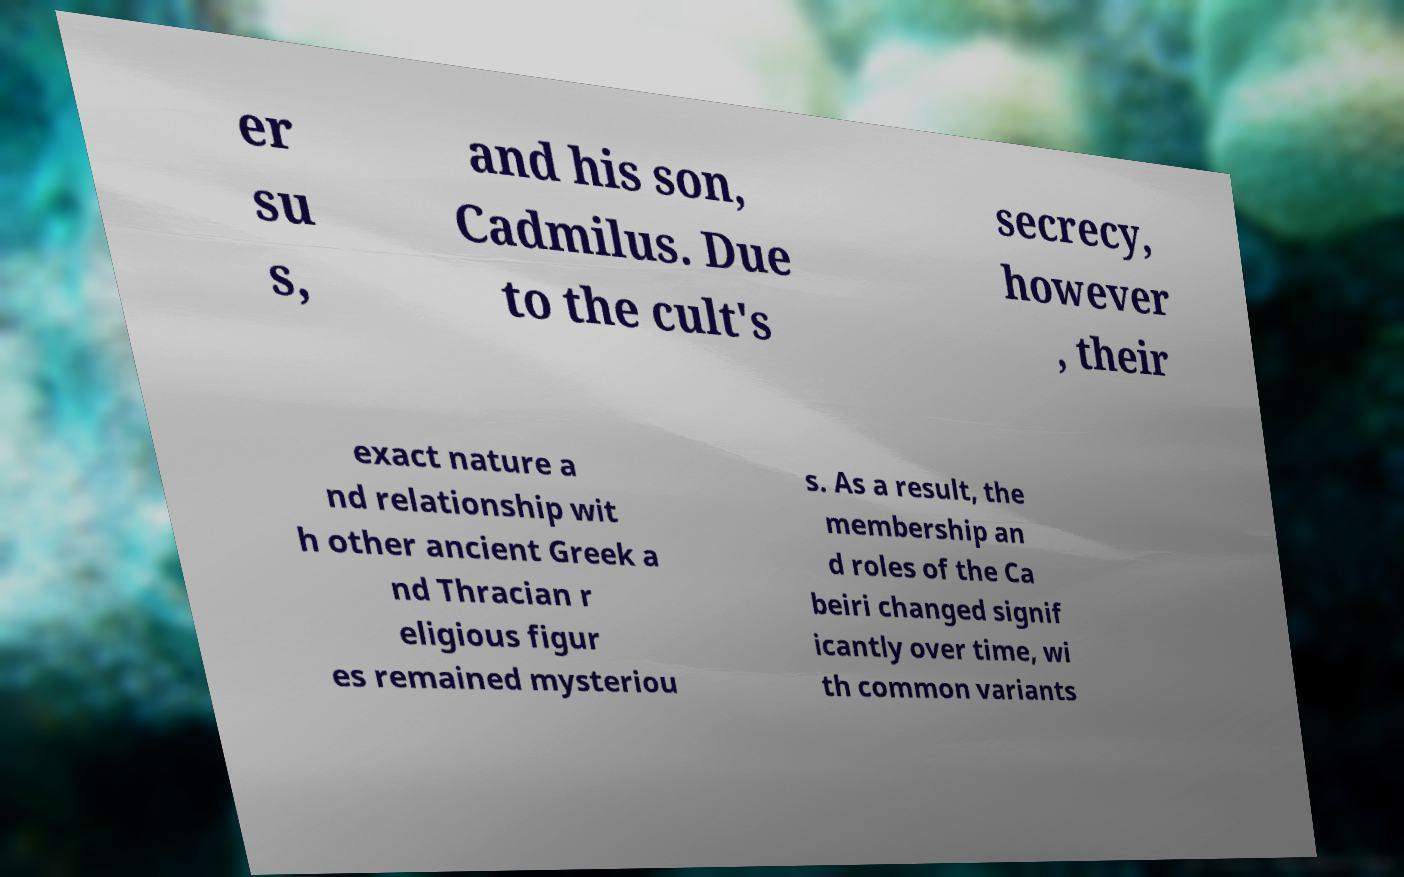What messages or text are displayed in this image? I need them in a readable, typed format. er su s, and his son, Cadmilus. Due to the cult's secrecy, however , their exact nature a nd relationship wit h other ancient Greek a nd Thracian r eligious figur es remained mysteriou s. As a result, the membership an d roles of the Ca beiri changed signif icantly over time, wi th common variants 